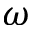Convert formula to latex. <formula><loc_0><loc_0><loc_500><loc_500>\omega</formula> 